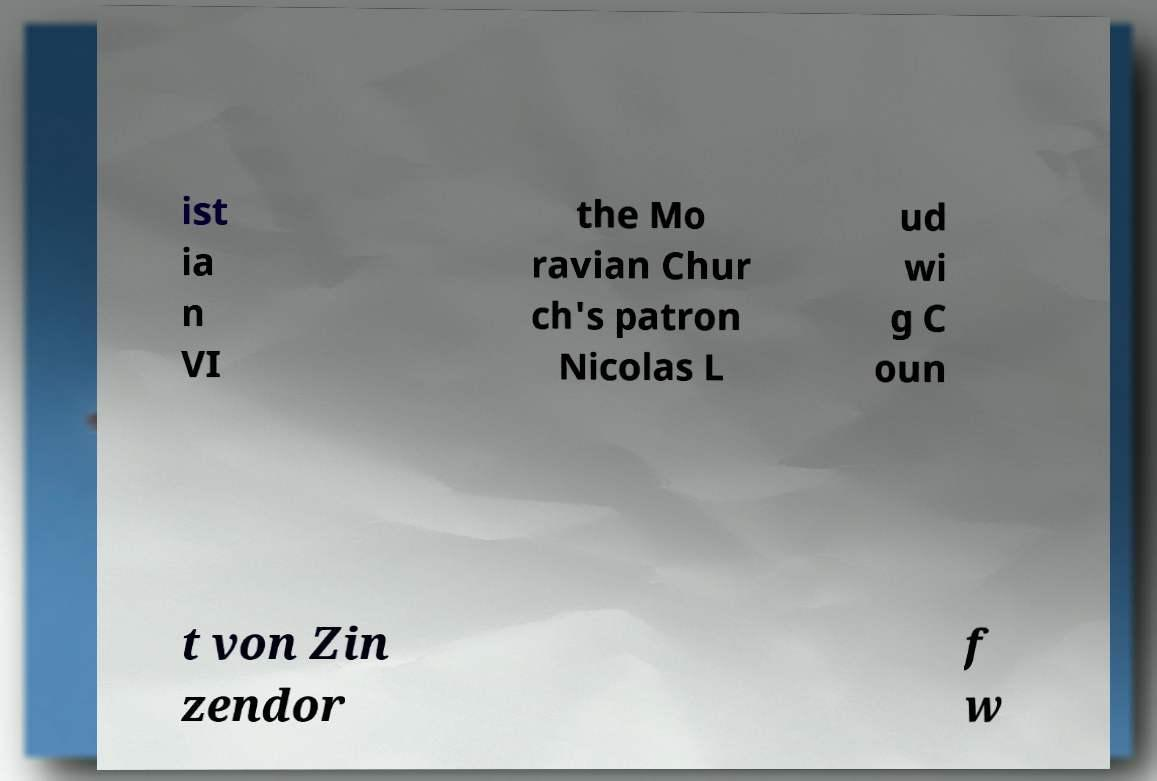What messages or text are displayed in this image? I need them in a readable, typed format. ist ia n VI the Mo ravian Chur ch's patron Nicolas L ud wi g C oun t von Zin zendor f w 